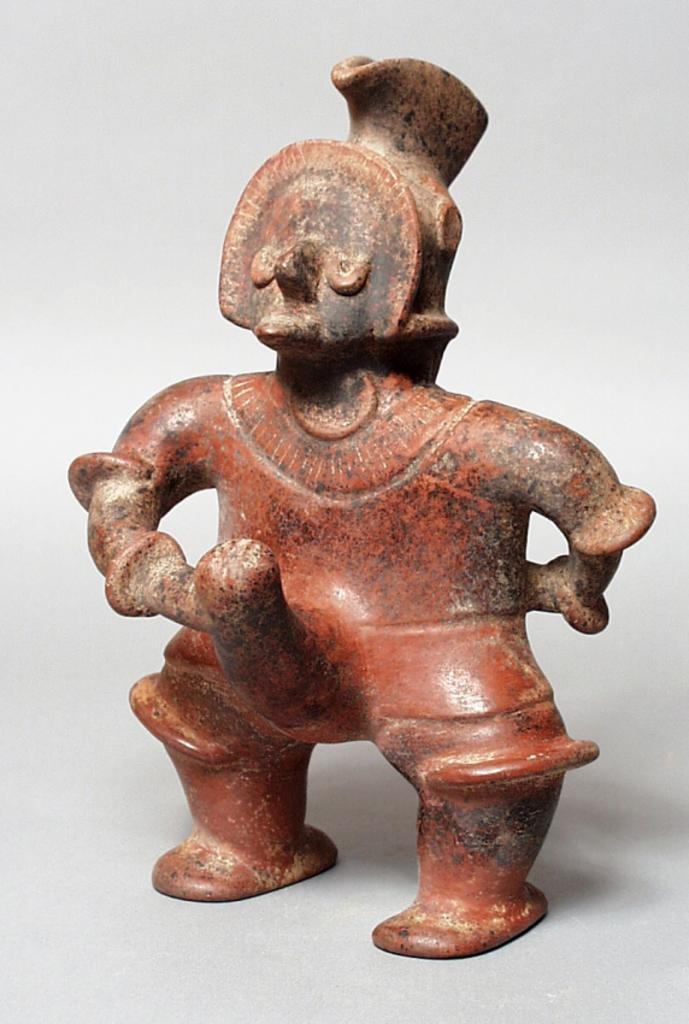What can be seen on the surface of the image? There is a depiction on the surface of the image. What color is the background of the image? The background of the image is white. What type of ring can be seen on the person's finger in the image? There is no person or ring present in the image; it only contains a depiction on the surface and a white background. 